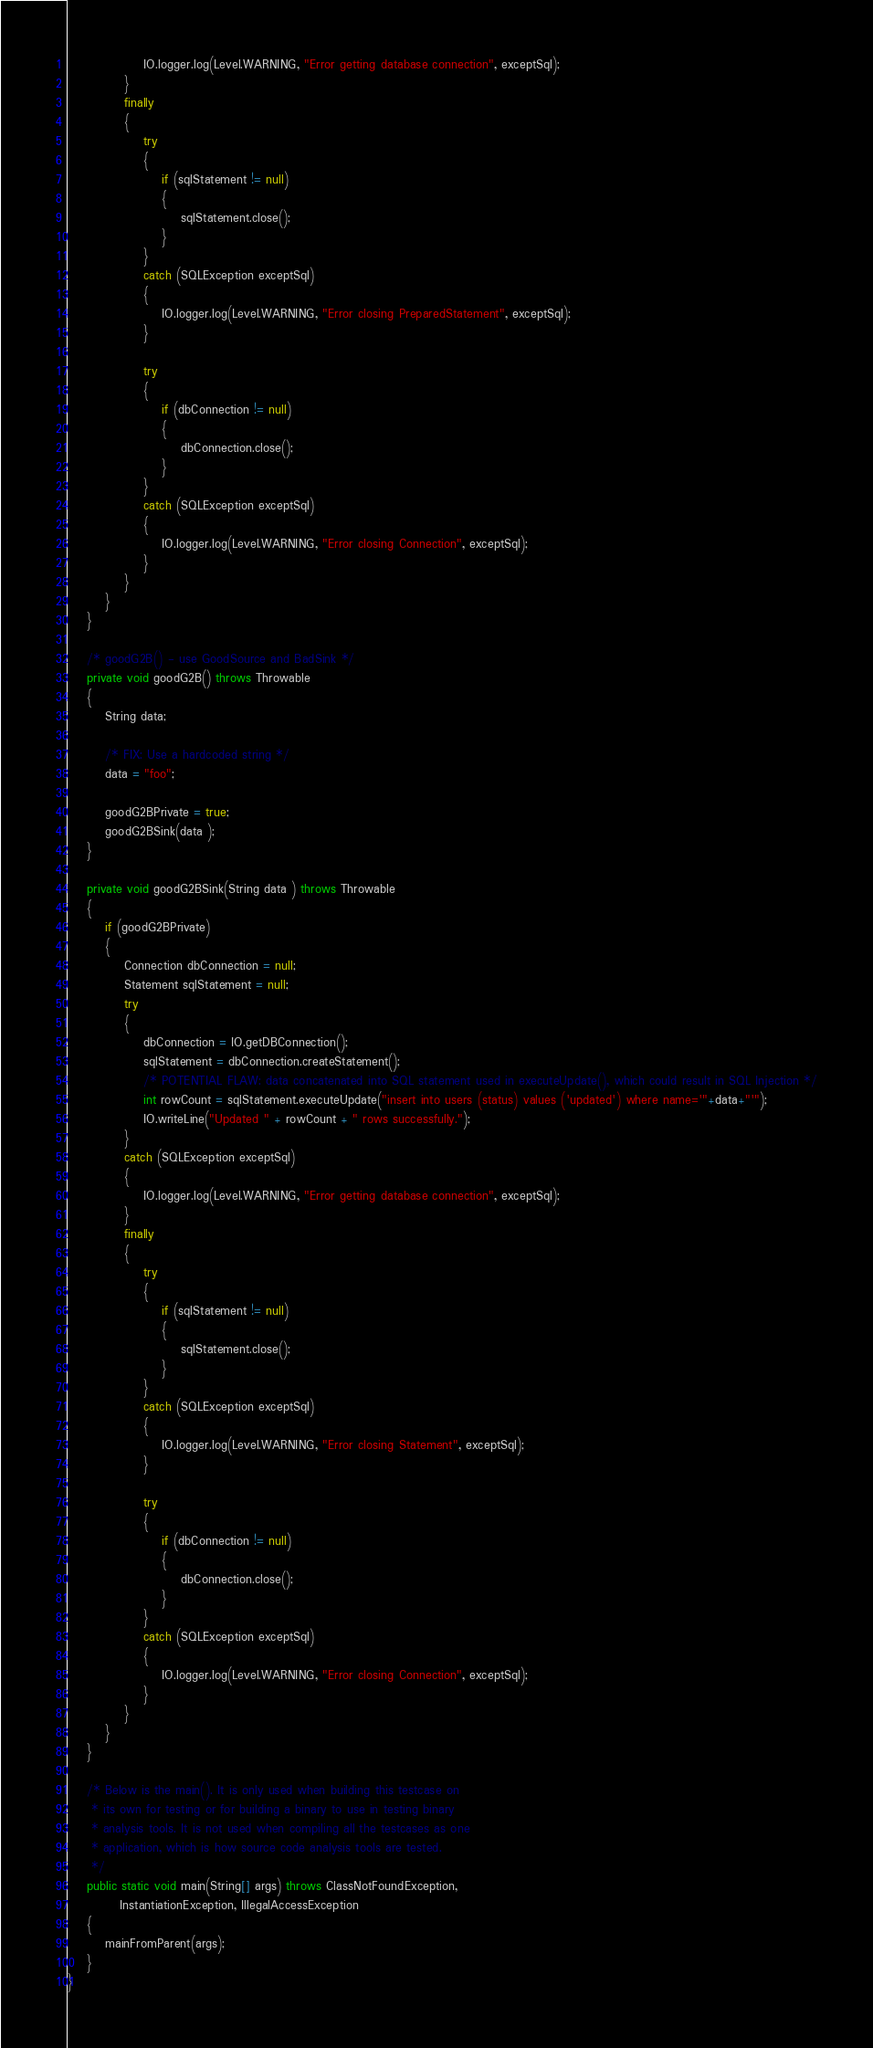Convert code to text. <code><loc_0><loc_0><loc_500><loc_500><_Java_>                IO.logger.log(Level.WARNING, "Error getting database connection", exceptSql);
            }
            finally
            {
                try
                {
                    if (sqlStatement != null)
                    {
                        sqlStatement.close();
                    }
                }
                catch (SQLException exceptSql)
                {
                    IO.logger.log(Level.WARNING, "Error closing PreparedStatement", exceptSql);
                }

                try
                {
                    if (dbConnection != null)
                    {
                        dbConnection.close();
                    }
                }
                catch (SQLException exceptSql)
                {
                    IO.logger.log(Level.WARNING, "Error closing Connection", exceptSql);
                }
            }
        }
    }

    /* goodG2B() - use GoodSource and BadSink */
    private void goodG2B() throws Throwable
    {
        String data;

        /* FIX: Use a hardcoded string */
        data = "foo";

        goodG2BPrivate = true;
        goodG2BSink(data );
    }

    private void goodG2BSink(String data ) throws Throwable
    {
        if (goodG2BPrivate)
        {
            Connection dbConnection = null;
            Statement sqlStatement = null;
            try
            {
                dbConnection = IO.getDBConnection();
                sqlStatement = dbConnection.createStatement();
                /* POTENTIAL FLAW: data concatenated into SQL statement used in executeUpdate(), which could result in SQL Injection */
                int rowCount = sqlStatement.executeUpdate("insert into users (status) values ('updated') where name='"+data+"'");
                IO.writeLine("Updated " + rowCount + " rows successfully.");
            }
            catch (SQLException exceptSql)
            {
                IO.logger.log(Level.WARNING, "Error getting database connection", exceptSql);
            }
            finally
            {
                try
                {
                    if (sqlStatement != null)
                    {
                        sqlStatement.close();
                    }
                }
                catch (SQLException exceptSql)
                {
                    IO.logger.log(Level.WARNING, "Error closing Statement", exceptSql);
                }

                try
                {
                    if (dbConnection != null)
                    {
                        dbConnection.close();
                    }
                }
                catch (SQLException exceptSql)
                {
                    IO.logger.log(Level.WARNING, "Error closing Connection", exceptSql);
                }
            }
        }
    }

    /* Below is the main(). It is only used when building this testcase on
     * its own for testing or for building a binary to use in testing binary
     * analysis tools. It is not used when compiling all the testcases as one
     * application, which is how source code analysis tools are tested.
     */
    public static void main(String[] args) throws ClassNotFoundException,
           InstantiationException, IllegalAccessException
    {
        mainFromParent(args);
    }
}
</code> 